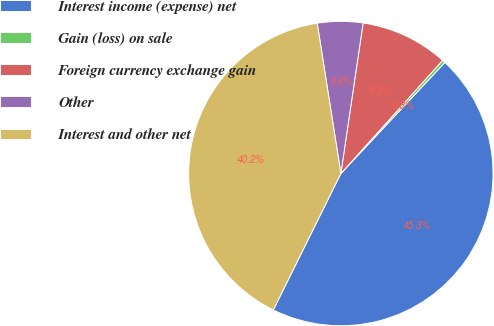Convert chart to OTSL. <chart><loc_0><loc_0><loc_500><loc_500><pie_chart><fcel>Interest income (expense) net<fcel>Gain (loss) on sale<fcel>Foreign currency exchange gain<fcel>Other<fcel>Interest and other net<nl><fcel>45.34%<fcel>0.32%<fcel>9.32%<fcel>4.82%<fcel>40.2%<nl></chart> 